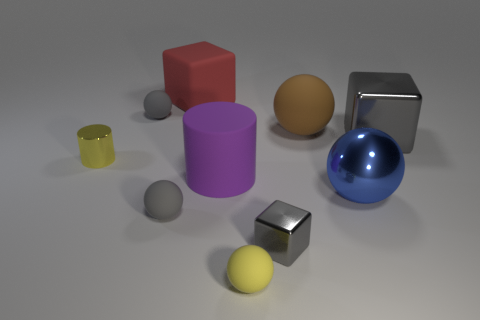There is a big metallic block in front of the large red matte thing; what color is it?
Ensure brevity in your answer.  Gray. Are there any green metallic things of the same shape as the red rubber thing?
Offer a very short reply. No. What is the material of the brown sphere?
Ensure brevity in your answer.  Rubber. How big is the block that is both behind the large cylinder and in front of the large red block?
Offer a very short reply. Large. What is the material of the thing that is the same color as the small cylinder?
Offer a very short reply. Rubber. What number of large brown rubber cylinders are there?
Give a very brief answer. 0. Is the number of big spheres less than the number of tiny yellow balls?
Give a very brief answer. No. There is a yellow ball that is the same size as the yellow metal thing; what material is it?
Keep it short and to the point. Rubber. What number of objects are tiny green metallic cylinders or metal objects?
Your response must be concise. 4. What number of tiny things are both left of the small gray metal object and in front of the large blue ball?
Your answer should be very brief. 2. 